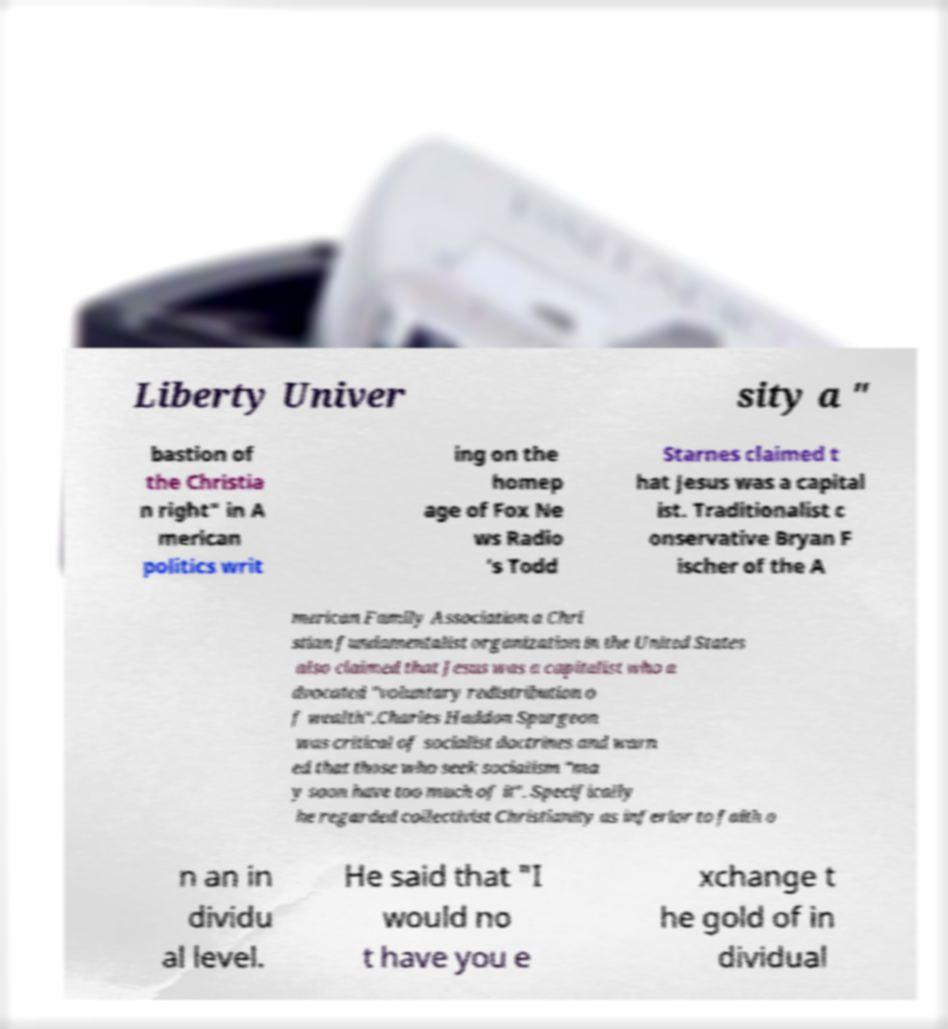Can you accurately transcribe the text from the provided image for me? Liberty Univer sity a " bastion of the Christia n right" in A merican politics writ ing on the homep age of Fox Ne ws Radio 's Todd Starnes claimed t hat Jesus was a capital ist. Traditionalist c onservative Bryan F ischer of the A merican Family Association a Chri stian fundamentalist organization in the United States also claimed that Jesus was a capitalist who a dvocated "voluntary redistribution o f wealth".Charles Haddon Spurgeon was critical of socialist doctrines and warn ed that those who seek socialism "ma y soon have too much of it". Specifically he regarded collectivist Christianity as inferior to faith o n an in dividu al level. He said that "I would no t have you e xchange t he gold of in dividual 